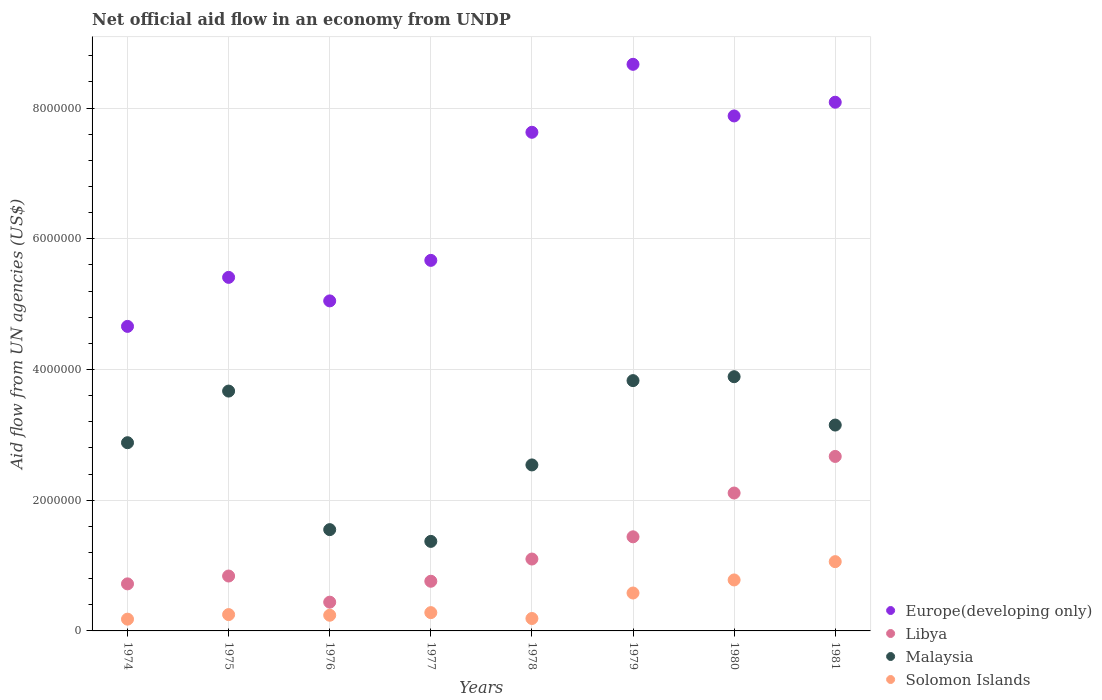How many different coloured dotlines are there?
Your response must be concise. 4. Is the number of dotlines equal to the number of legend labels?
Your answer should be compact. Yes. What is the net official aid flow in Libya in 1981?
Offer a terse response. 2.67e+06. Across all years, what is the maximum net official aid flow in Malaysia?
Offer a terse response. 3.89e+06. Across all years, what is the minimum net official aid flow in Europe(developing only)?
Your answer should be compact. 4.66e+06. In which year was the net official aid flow in Malaysia maximum?
Provide a succinct answer. 1980. In which year was the net official aid flow in Solomon Islands minimum?
Provide a short and direct response. 1974. What is the total net official aid flow in Libya in the graph?
Your response must be concise. 1.01e+07. What is the difference between the net official aid flow in Solomon Islands in 1975 and that in 1977?
Provide a succinct answer. -3.00e+04. What is the difference between the net official aid flow in Solomon Islands in 1981 and the net official aid flow in Libya in 1976?
Your answer should be compact. 6.20e+05. What is the average net official aid flow in Solomon Islands per year?
Your response must be concise. 4.45e+05. In how many years, is the net official aid flow in Europe(developing only) greater than 4000000 US$?
Offer a very short reply. 8. What is the ratio of the net official aid flow in Solomon Islands in 1976 to that in 1979?
Ensure brevity in your answer.  0.41. Is the net official aid flow in Libya in 1979 less than that in 1981?
Make the answer very short. Yes. Is the difference between the net official aid flow in Libya in 1975 and 1979 greater than the difference between the net official aid flow in Solomon Islands in 1975 and 1979?
Offer a terse response. No. What is the difference between the highest and the lowest net official aid flow in Europe(developing only)?
Your answer should be compact. 4.01e+06. In how many years, is the net official aid flow in Malaysia greater than the average net official aid flow in Malaysia taken over all years?
Keep it short and to the point. 5. Is it the case that in every year, the sum of the net official aid flow in Solomon Islands and net official aid flow in Europe(developing only)  is greater than the net official aid flow in Malaysia?
Your answer should be compact. Yes. Is the net official aid flow in Solomon Islands strictly greater than the net official aid flow in Malaysia over the years?
Provide a short and direct response. No. How many dotlines are there?
Your answer should be very brief. 4. What is the difference between two consecutive major ticks on the Y-axis?
Keep it short and to the point. 2.00e+06. Are the values on the major ticks of Y-axis written in scientific E-notation?
Offer a very short reply. No. Does the graph contain any zero values?
Give a very brief answer. No. Does the graph contain grids?
Make the answer very short. Yes. Where does the legend appear in the graph?
Provide a succinct answer. Bottom right. How many legend labels are there?
Make the answer very short. 4. What is the title of the graph?
Your response must be concise. Net official aid flow in an economy from UNDP. Does "Denmark" appear as one of the legend labels in the graph?
Your answer should be very brief. No. What is the label or title of the X-axis?
Offer a very short reply. Years. What is the label or title of the Y-axis?
Provide a short and direct response. Aid flow from UN agencies (US$). What is the Aid flow from UN agencies (US$) in Europe(developing only) in 1974?
Offer a terse response. 4.66e+06. What is the Aid flow from UN agencies (US$) in Libya in 1974?
Keep it short and to the point. 7.20e+05. What is the Aid flow from UN agencies (US$) in Malaysia in 1974?
Offer a very short reply. 2.88e+06. What is the Aid flow from UN agencies (US$) of Solomon Islands in 1974?
Offer a very short reply. 1.80e+05. What is the Aid flow from UN agencies (US$) of Europe(developing only) in 1975?
Offer a terse response. 5.41e+06. What is the Aid flow from UN agencies (US$) in Libya in 1975?
Offer a very short reply. 8.40e+05. What is the Aid flow from UN agencies (US$) in Malaysia in 1975?
Offer a very short reply. 3.67e+06. What is the Aid flow from UN agencies (US$) in Europe(developing only) in 1976?
Your answer should be compact. 5.05e+06. What is the Aid flow from UN agencies (US$) in Malaysia in 1976?
Provide a succinct answer. 1.55e+06. What is the Aid flow from UN agencies (US$) of Europe(developing only) in 1977?
Ensure brevity in your answer.  5.67e+06. What is the Aid flow from UN agencies (US$) in Libya in 1977?
Provide a succinct answer. 7.60e+05. What is the Aid flow from UN agencies (US$) of Malaysia in 1977?
Keep it short and to the point. 1.37e+06. What is the Aid flow from UN agencies (US$) of Europe(developing only) in 1978?
Offer a very short reply. 7.63e+06. What is the Aid flow from UN agencies (US$) of Libya in 1978?
Give a very brief answer. 1.10e+06. What is the Aid flow from UN agencies (US$) in Malaysia in 1978?
Keep it short and to the point. 2.54e+06. What is the Aid flow from UN agencies (US$) of Europe(developing only) in 1979?
Offer a terse response. 8.67e+06. What is the Aid flow from UN agencies (US$) of Libya in 1979?
Offer a terse response. 1.44e+06. What is the Aid flow from UN agencies (US$) in Malaysia in 1979?
Provide a succinct answer. 3.83e+06. What is the Aid flow from UN agencies (US$) of Solomon Islands in 1979?
Provide a short and direct response. 5.80e+05. What is the Aid flow from UN agencies (US$) in Europe(developing only) in 1980?
Your answer should be compact. 7.88e+06. What is the Aid flow from UN agencies (US$) of Libya in 1980?
Your response must be concise. 2.11e+06. What is the Aid flow from UN agencies (US$) in Malaysia in 1980?
Your answer should be compact. 3.89e+06. What is the Aid flow from UN agencies (US$) in Solomon Islands in 1980?
Your response must be concise. 7.80e+05. What is the Aid flow from UN agencies (US$) of Europe(developing only) in 1981?
Give a very brief answer. 8.09e+06. What is the Aid flow from UN agencies (US$) in Libya in 1981?
Your answer should be very brief. 2.67e+06. What is the Aid flow from UN agencies (US$) in Malaysia in 1981?
Offer a very short reply. 3.15e+06. What is the Aid flow from UN agencies (US$) of Solomon Islands in 1981?
Your answer should be very brief. 1.06e+06. Across all years, what is the maximum Aid flow from UN agencies (US$) of Europe(developing only)?
Offer a very short reply. 8.67e+06. Across all years, what is the maximum Aid flow from UN agencies (US$) in Libya?
Ensure brevity in your answer.  2.67e+06. Across all years, what is the maximum Aid flow from UN agencies (US$) of Malaysia?
Your answer should be compact. 3.89e+06. Across all years, what is the maximum Aid flow from UN agencies (US$) in Solomon Islands?
Make the answer very short. 1.06e+06. Across all years, what is the minimum Aid flow from UN agencies (US$) of Europe(developing only)?
Make the answer very short. 4.66e+06. Across all years, what is the minimum Aid flow from UN agencies (US$) of Malaysia?
Your response must be concise. 1.37e+06. What is the total Aid flow from UN agencies (US$) in Europe(developing only) in the graph?
Your response must be concise. 5.31e+07. What is the total Aid flow from UN agencies (US$) in Libya in the graph?
Ensure brevity in your answer.  1.01e+07. What is the total Aid flow from UN agencies (US$) of Malaysia in the graph?
Make the answer very short. 2.29e+07. What is the total Aid flow from UN agencies (US$) of Solomon Islands in the graph?
Provide a short and direct response. 3.56e+06. What is the difference between the Aid flow from UN agencies (US$) in Europe(developing only) in 1974 and that in 1975?
Offer a very short reply. -7.50e+05. What is the difference between the Aid flow from UN agencies (US$) of Libya in 1974 and that in 1975?
Ensure brevity in your answer.  -1.20e+05. What is the difference between the Aid flow from UN agencies (US$) in Malaysia in 1974 and that in 1975?
Offer a terse response. -7.90e+05. What is the difference between the Aid flow from UN agencies (US$) of Europe(developing only) in 1974 and that in 1976?
Your answer should be very brief. -3.90e+05. What is the difference between the Aid flow from UN agencies (US$) of Libya in 1974 and that in 1976?
Make the answer very short. 2.80e+05. What is the difference between the Aid flow from UN agencies (US$) in Malaysia in 1974 and that in 1976?
Your response must be concise. 1.33e+06. What is the difference between the Aid flow from UN agencies (US$) of Solomon Islands in 1974 and that in 1976?
Your response must be concise. -6.00e+04. What is the difference between the Aid flow from UN agencies (US$) in Europe(developing only) in 1974 and that in 1977?
Make the answer very short. -1.01e+06. What is the difference between the Aid flow from UN agencies (US$) of Libya in 1974 and that in 1977?
Offer a very short reply. -4.00e+04. What is the difference between the Aid flow from UN agencies (US$) of Malaysia in 1974 and that in 1977?
Provide a succinct answer. 1.51e+06. What is the difference between the Aid flow from UN agencies (US$) of Europe(developing only) in 1974 and that in 1978?
Offer a terse response. -2.97e+06. What is the difference between the Aid flow from UN agencies (US$) in Libya in 1974 and that in 1978?
Provide a short and direct response. -3.80e+05. What is the difference between the Aid flow from UN agencies (US$) in Europe(developing only) in 1974 and that in 1979?
Your answer should be very brief. -4.01e+06. What is the difference between the Aid flow from UN agencies (US$) in Libya in 1974 and that in 1979?
Give a very brief answer. -7.20e+05. What is the difference between the Aid flow from UN agencies (US$) of Malaysia in 1974 and that in 1979?
Make the answer very short. -9.50e+05. What is the difference between the Aid flow from UN agencies (US$) of Solomon Islands in 1974 and that in 1979?
Keep it short and to the point. -4.00e+05. What is the difference between the Aid flow from UN agencies (US$) of Europe(developing only) in 1974 and that in 1980?
Your response must be concise. -3.22e+06. What is the difference between the Aid flow from UN agencies (US$) in Libya in 1974 and that in 1980?
Ensure brevity in your answer.  -1.39e+06. What is the difference between the Aid flow from UN agencies (US$) of Malaysia in 1974 and that in 1980?
Your answer should be very brief. -1.01e+06. What is the difference between the Aid flow from UN agencies (US$) in Solomon Islands in 1974 and that in 1980?
Your answer should be very brief. -6.00e+05. What is the difference between the Aid flow from UN agencies (US$) in Europe(developing only) in 1974 and that in 1981?
Give a very brief answer. -3.43e+06. What is the difference between the Aid flow from UN agencies (US$) in Libya in 1974 and that in 1981?
Your response must be concise. -1.95e+06. What is the difference between the Aid flow from UN agencies (US$) of Solomon Islands in 1974 and that in 1981?
Provide a short and direct response. -8.80e+05. What is the difference between the Aid flow from UN agencies (US$) in Europe(developing only) in 1975 and that in 1976?
Offer a terse response. 3.60e+05. What is the difference between the Aid flow from UN agencies (US$) in Libya in 1975 and that in 1976?
Provide a short and direct response. 4.00e+05. What is the difference between the Aid flow from UN agencies (US$) of Malaysia in 1975 and that in 1976?
Make the answer very short. 2.12e+06. What is the difference between the Aid flow from UN agencies (US$) in Malaysia in 1975 and that in 1977?
Provide a short and direct response. 2.30e+06. What is the difference between the Aid flow from UN agencies (US$) in Europe(developing only) in 1975 and that in 1978?
Give a very brief answer. -2.22e+06. What is the difference between the Aid flow from UN agencies (US$) of Malaysia in 1975 and that in 1978?
Your answer should be very brief. 1.13e+06. What is the difference between the Aid flow from UN agencies (US$) of Solomon Islands in 1975 and that in 1978?
Offer a very short reply. 6.00e+04. What is the difference between the Aid flow from UN agencies (US$) in Europe(developing only) in 1975 and that in 1979?
Ensure brevity in your answer.  -3.26e+06. What is the difference between the Aid flow from UN agencies (US$) in Libya in 1975 and that in 1979?
Keep it short and to the point. -6.00e+05. What is the difference between the Aid flow from UN agencies (US$) of Solomon Islands in 1975 and that in 1979?
Your answer should be compact. -3.30e+05. What is the difference between the Aid flow from UN agencies (US$) of Europe(developing only) in 1975 and that in 1980?
Your answer should be compact. -2.47e+06. What is the difference between the Aid flow from UN agencies (US$) in Libya in 1975 and that in 1980?
Provide a short and direct response. -1.27e+06. What is the difference between the Aid flow from UN agencies (US$) in Malaysia in 1975 and that in 1980?
Ensure brevity in your answer.  -2.20e+05. What is the difference between the Aid flow from UN agencies (US$) in Solomon Islands in 1975 and that in 1980?
Your answer should be compact. -5.30e+05. What is the difference between the Aid flow from UN agencies (US$) of Europe(developing only) in 1975 and that in 1981?
Provide a succinct answer. -2.68e+06. What is the difference between the Aid flow from UN agencies (US$) in Libya in 1975 and that in 1981?
Provide a succinct answer. -1.83e+06. What is the difference between the Aid flow from UN agencies (US$) of Malaysia in 1975 and that in 1981?
Offer a very short reply. 5.20e+05. What is the difference between the Aid flow from UN agencies (US$) of Solomon Islands in 1975 and that in 1981?
Make the answer very short. -8.10e+05. What is the difference between the Aid flow from UN agencies (US$) of Europe(developing only) in 1976 and that in 1977?
Provide a succinct answer. -6.20e+05. What is the difference between the Aid flow from UN agencies (US$) of Libya in 1976 and that in 1977?
Ensure brevity in your answer.  -3.20e+05. What is the difference between the Aid flow from UN agencies (US$) of Solomon Islands in 1976 and that in 1977?
Make the answer very short. -4.00e+04. What is the difference between the Aid flow from UN agencies (US$) of Europe(developing only) in 1976 and that in 1978?
Offer a terse response. -2.58e+06. What is the difference between the Aid flow from UN agencies (US$) in Libya in 1976 and that in 1978?
Offer a very short reply. -6.60e+05. What is the difference between the Aid flow from UN agencies (US$) in Malaysia in 1976 and that in 1978?
Keep it short and to the point. -9.90e+05. What is the difference between the Aid flow from UN agencies (US$) in Europe(developing only) in 1976 and that in 1979?
Offer a terse response. -3.62e+06. What is the difference between the Aid flow from UN agencies (US$) in Malaysia in 1976 and that in 1979?
Offer a terse response. -2.28e+06. What is the difference between the Aid flow from UN agencies (US$) of Europe(developing only) in 1976 and that in 1980?
Give a very brief answer. -2.83e+06. What is the difference between the Aid flow from UN agencies (US$) in Libya in 1976 and that in 1980?
Offer a terse response. -1.67e+06. What is the difference between the Aid flow from UN agencies (US$) of Malaysia in 1976 and that in 1980?
Your answer should be very brief. -2.34e+06. What is the difference between the Aid flow from UN agencies (US$) of Solomon Islands in 1976 and that in 1980?
Give a very brief answer. -5.40e+05. What is the difference between the Aid flow from UN agencies (US$) of Europe(developing only) in 1976 and that in 1981?
Provide a short and direct response. -3.04e+06. What is the difference between the Aid flow from UN agencies (US$) of Libya in 1976 and that in 1981?
Your response must be concise. -2.23e+06. What is the difference between the Aid flow from UN agencies (US$) of Malaysia in 1976 and that in 1981?
Your answer should be compact. -1.60e+06. What is the difference between the Aid flow from UN agencies (US$) of Solomon Islands in 1976 and that in 1981?
Provide a succinct answer. -8.20e+05. What is the difference between the Aid flow from UN agencies (US$) in Europe(developing only) in 1977 and that in 1978?
Your answer should be very brief. -1.96e+06. What is the difference between the Aid flow from UN agencies (US$) of Libya in 1977 and that in 1978?
Give a very brief answer. -3.40e+05. What is the difference between the Aid flow from UN agencies (US$) in Malaysia in 1977 and that in 1978?
Keep it short and to the point. -1.17e+06. What is the difference between the Aid flow from UN agencies (US$) of Europe(developing only) in 1977 and that in 1979?
Ensure brevity in your answer.  -3.00e+06. What is the difference between the Aid flow from UN agencies (US$) in Libya in 1977 and that in 1979?
Provide a succinct answer. -6.80e+05. What is the difference between the Aid flow from UN agencies (US$) of Malaysia in 1977 and that in 1979?
Make the answer very short. -2.46e+06. What is the difference between the Aid flow from UN agencies (US$) in Europe(developing only) in 1977 and that in 1980?
Provide a short and direct response. -2.21e+06. What is the difference between the Aid flow from UN agencies (US$) in Libya in 1977 and that in 1980?
Keep it short and to the point. -1.35e+06. What is the difference between the Aid flow from UN agencies (US$) in Malaysia in 1977 and that in 1980?
Ensure brevity in your answer.  -2.52e+06. What is the difference between the Aid flow from UN agencies (US$) of Solomon Islands in 1977 and that in 1980?
Provide a succinct answer. -5.00e+05. What is the difference between the Aid flow from UN agencies (US$) in Europe(developing only) in 1977 and that in 1981?
Your answer should be compact. -2.42e+06. What is the difference between the Aid flow from UN agencies (US$) in Libya in 1977 and that in 1981?
Give a very brief answer. -1.91e+06. What is the difference between the Aid flow from UN agencies (US$) of Malaysia in 1977 and that in 1981?
Provide a short and direct response. -1.78e+06. What is the difference between the Aid flow from UN agencies (US$) of Solomon Islands in 1977 and that in 1981?
Give a very brief answer. -7.80e+05. What is the difference between the Aid flow from UN agencies (US$) in Europe(developing only) in 1978 and that in 1979?
Your answer should be very brief. -1.04e+06. What is the difference between the Aid flow from UN agencies (US$) of Libya in 1978 and that in 1979?
Your answer should be very brief. -3.40e+05. What is the difference between the Aid flow from UN agencies (US$) of Malaysia in 1978 and that in 1979?
Your answer should be very brief. -1.29e+06. What is the difference between the Aid flow from UN agencies (US$) in Solomon Islands in 1978 and that in 1979?
Your answer should be very brief. -3.90e+05. What is the difference between the Aid flow from UN agencies (US$) in Libya in 1978 and that in 1980?
Your answer should be compact. -1.01e+06. What is the difference between the Aid flow from UN agencies (US$) of Malaysia in 1978 and that in 1980?
Keep it short and to the point. -1.35e+06. What is the difference between the Aid flow from UN agencies (US$) in Solomon Islands in 1978 and that in 1980?
Your answer should be compact. -5.90e+05. What is the difference between the Aid flow from UN agencies (US$) in Europe(developing only) in 1978 and that in 1981?
Provide a succinct answer. -4.60e+05. What is the difference between the Aid flow from UN agencies (US$) of Libya in 1978 and that in 1981?
Your answer should be compact. -1.57e+06. What is the difference between the Aid flow from UN agencies (US$) of Malaysia in 1978 and that in 1981?
Make the answer very short. -6.10e+05. What is the difference between the Aid flow from UN agencies (US$) in Solomon Islands in 1978 and that in 1981?
Your answer should be compact. -8.70e+05. What is the difference between the Aid flow from UN agencies (US$) in Europe(developing only) in 1979 and that in 1980?
Provide a short and direct response. 7.90e+05. What is the difference between the Aid flow from UN agencies (US$) of Libya in 1979 and that in 1980?
Your answer should be very brief. -6.70e+05. What is the difference between the Aid flow from UN agencies (US$) in Europe(developing only) in 1979 and that in 1981?
Keep it short and to the point. 5.80e+05. What is the difference between the Aid flow from UN agencies (US$) in Libya in 1979 and that in 1981?
Keep it short and to the point. -1.23e+06. What is the difference between the Aid flow from UN agencies (US$) of Malaysia in 1979 and that in 1981?
Provide a succinct answer. 6.80e+05. What is the difference between the Aid flow from UN agencies (US$) in Solomon Islands in 1979 and that in 1981?
Your answer should be compact. -4.80e+05. What is the difference between the Aid flow from UN agencies (US$) of Libya in 1980 and that in 1981?
Provide a short and direct response. -5.60e+05. What is the difference between the Aid flow from UN agencies (US$) of Malaysia in 1980 and that in 1981?
Ensure brevity in your answer.  7.40e+05. What is the difference between the Aid flow from UN agencies (US$) of Solomon Islands in 1980 and that in 1981?
Your answer should be compact. -2.80e+05. What is the difference between the Aid flow from UN agencies (US$) in Europe(developing only) in 1974 and the Aid flow from UN agencies (US$) in Libya in 1975?
Keep it short and to the point. 3.82e+06. What is the difference between the Aid flow from UN agencies (US$) in Europe(developing only) in 1974 and the Aid flow from UN agencies (US$) in Malaysia in 1975?
Give a very brief answer. 9.90e+05. What is the difference between the Aid flow from UN agencies (US$) in Europe(developing only) in 1974 and the Aid flow from UN agencies (US$) in Solomon Islands in 1975?
Provide a succinct answer. 4.41e+06. What is the difference between the Aid flow from UN agencies (US$) in Libya in 1974 and the Aid flow from UN agencies (US$) in Malaysia in 1975?
Provide a short and direct response. -2.95e+06. What is the difference between the Aid flow from UN agencies (US$) of Libya in 1974 and the Aid flow from UN agencies (US$) of Solomon Islands in 1975?
Provide a succinct answer. 4.70e+05. What is the difference between the Aid flow from UN agencies (US$) of Malaysia in 1974 and the Aid flow from UN agencies (US$) of Solomon Islands in 1975?
Ensure brevity in your answer.  2.63e+06. What is the difference between the Aid flow from UN agencies (US$) of Europe(developing only) in 1974 and the Aid flow from UN agencies (US$) of Libya in 1976?
Make the answer very short. 4.22e+06. What is the difference between the Aid flow from UN agencies (US$) of Europe(developing only) in 1974 and the Aid flow from UN agencies (US$) of Malaysia in 1976?
Your response must be concise. 3.11e+06. What is the difference between the Aid flow from UN agencies (US$) of Europe(developing only) in 1974 and the Aid flow from UN agencies (US$) of Solomon Islands in 1976?
Ensure brevity in your answer.  4.42e+06. What is the difference between the Aid flow from UN agencies (US$) in Libya in 1974 and the Aid flow from UN agencies (US$) in Malaysia in 1976?
Your response must be concise. -8.30e+05. What is the difference between the Aid flow from UN agencies (US$) of Malaysia in 1974 and the Aid flow from UN agencies (US$) of Solomon Islands in 1976?
Your response must be concise. 2.64e+06. What is the difference between the Aid flow from UN agencies (US$) of Europe(developing only) in 1974 and the Aid flow from UN agencies (US$) of Libya in 1977?
Provide a succinct answer. 3.90e+06. What is the difference between the Aid flow from UN agencies (US$) of Europe(developing only) in 1974 and the Aid flow from UN agencies (US$) of Malaysia in 1977?
Ensure brevity in your answer.  3.29e+06. What is the difference between the Aid flow from UN agencies (US$) of Europe(developing only) in 1974 and the Aid flow from UN agencies (US$) of Solomon Islands in 1977?
Your response must be concise. 4.38e+06. What is the difference between the Aid flow from UN agencies (US$) in Libya in 1974 and the Aid flow from UN agencies (US$) in Malaysia in 1977?
Offer a very short reply. -6.50e+05. What is the difference between the Aid flow from UN agencies (US$) of Malaysia in 1974 and the Aid flow from UN agencies (US$) of Solomon Islands in 1977?
Provide a succinct answer. 2.60e+06. What is the difference between the Aid flow from UN agencies (US$) of Europe(developing only) in 1974 and the Aid flow from UN agencies (US$) of Libya in 1978?
Offer a very short reply. 3.56e+06. What is the difference between the Aid flow from UN agencies (US$) of Europe(developing only) in 1974 and the Aid flow from UN agencies (US$) of Malaysia in 1978?
Give a very brief answer. 2.12e+06. What is the difference between the Aid flow from UN agencies (US$) of Europe(developing only) in 1974 and the Aid flow from UN agencies (US$) of Solomon Islands in 1978?
Keep it short and to the point. 4.47e+06. What is the difference between the Aid flow from UN agencies (US$) in Libya in 1974 and the Aid flow from UN agencies (US$) in Malaysia in 1978?
Your answer should be compact. -1.82e+06. What is the difference between the Aid flow from UN agencies (US$) of Libya in 1974 and the Aid flow from UN agencies (US$) of Solomon Islands in 1978?
Your answer should be compact. 5.30e+05. What is the difference between the Aid flow from UN agencies (US$) in Malaysia in 1974 and the Aid flow from UN agencies (US$) in Solomon Islands in 1978?
Your answer should be very brief. 2.69e+06. What is the difference between the Aid flow from UN agencies (US$) in Europe(developing only) in 1974 and the Aid flow from UN agencies (US$) in Libya in 1979?
Your answer should be very brief. 3.22e+06. What is the difference between the Aid flow from UN agencies (US$) in Europe(developing only) in 1974 and the Aid flow from UN agencies (US$) in Malaysia in 1979?
Provide a short and direct response. 8.30e+05. What is the difference between the Aid flow from UN agencies (US$) of Europe(developing only) in 1974 and the Aid flow from UN agencies (US$) of Solomon Islands in 1979?
Your answer should be very brief. 4.08e+06. What is the difference between the Aid flow from UN agencies (US$) in Libya in 1974 and the Aid flow from UN agencies (US$) in Malaysia in 1979?
Provide a succinct answer. -3.11e+06. What is the difference between the Aid flow from UN agencies (US$) in Libya in 1974 and the Aid flow from UN agencies (US$) in Solomon Islands in 1979?
Your answer should be very brief. 1.40e+05. What is the difference between the Aid flow from UN agencies (US$) in Malaysia in 1974 and the Aid flow from UN agencies (US$) in Solomon Islands in 1979?
Keep it short and to the point. 2.30e+06. What is the difference between the Aid flow from UN agencies (US$) of Europe(developing only) in 1974 and the Aid flow from UN agencies (US$) of Libya in 1980?
Offer a terse response. 2.55e+06. What is the difference between the Aid flow from UN agencies (US$) of Europe(developing only) in 1974 and the Aid flow from UN agencies (US$) of Malaysia in 1980?
Provide a succinct answer. 7.70e+05. What is the difference between the Aid flow from UN agencies (US$) of Europe(developing only) in 1974 and the Aid flow from UN agencies (US$) of Solomon Islands in 1980?
Your answer should be compact. 3.88e+06. What is the difference between the Aid flow from UN agencies (US$) of Libya in 1974 and the Aid flow from UN agencies (US$) of Malaysia in 1980?
Provide a succinct answer. -3.17e+06. What is the difference between the Aid flow from UN agencies (US$) in Libya in 1974 and the Aid flow from UN agencies (US$) in Solomon Islands in 1980?
Provide a succinct answer. -6.00e+04. What is the difference between the Aid flow from UN agencies (US$) in Malaysia in 1974 and the Aid flow from UN agencies (US$) in Solomon Islands in 1980?
Keep it short and to the point. 2.10e+06. What is the difference between the Aid flow from UN agencies (US$) of Europe(developing only) in 1974 and the Aid flow from UN agencies (US$) of Libya in 1981?
Your answer should be compact. 1.99e+06. What is the difference between the Aid flow from UN agencies (US$) of Europe(developing only) in 1974 and the Aid flow from UN agencies (US$) of Malaysia in 1981?
Give a very brief answer. 1.51e+06. What is the difference between the Aid flow from UN agencies (US$) in Europe(developing only) in 1974 and the Aid flow from UN agencies (US$) in Solomon Islands in 1981?
Offer a very short reply. 3.60e+06. What is the difference between the Aid flow from UN agencies (US$) of Libya in 1974 and the Aid flow from UN agencies (US$) of Malaysia in 1981?
Provide a short and direct response. -2.43e+06. What is the difference between the Aid flow from UN agencies (US$) in Malaysia in 1974 and the Aid flow from UN agencies (US$) in Solomon Islands in 1981?
Provide a succinct answer. 1.82e+06. What is the difference between the Aid flow from UN agencies (US$) of Europe(developing only) in 1975 and the Aid flow from UN agencies (US$) of Libya in 1976?
Keep it short and to the point. 4.97e+06. What is the difference between the Aid flow from UN agencies (US$) of Europe(developing only) in 1975 and the Aid flow from UN agencies (US$) of Malaysia in 1976?
Provide a short and direct response. 3.86e+06. What is the difference between the Aid flow from UN agencies (US$) of Europe(developing only) in 1975 and the Aid flow from UN agencies (US$) of Solomon Islands in 1976?
Keep it short and to the point. 5.17e+06. What is the difference between the Aid flow from UN agencies (US$) of Libya in 1975 and the Aid flow from UN agencies (US$) of Malaysia in 1976?
Give a very brief answer. -7.10e+05. What is the difference between the Aid flow from UN agencies (US$) of Malaysia in 1975 and the Aid flow from UN agencies (US$) of Solomon Islands in 1976?
Give a very brief answer. 3.43e+06. What is the difference between the Aid flow from UN agencies (US$) in Europe(developing only) in 1975 and the Aid flow from UN agencies (US$) in Libya in 1977?
Provide a succinct answer. 4.65e+06. What is the difference between the Aid flow from UN agencies (US$) in Europe(developing only) in 1975 and the Aid flow from UN agencies (US$) in Malaysia in 1977?
Keep it short and to the point. 4.04e+06. What is the difference between the Aid flow from UN agencies (US$) of Europe(developing only) in 1975 and the Aid flow from UN agencies (US$) of Solomon Islands in 1977?
Provide a succinct answer. 5.13e+06. What is the difference between the Aid flow from UN agencies (US$) in Libya in 1975 and the Aid flow from UN agencies (US$) in Malaysia in 1977?
Make the answer very short. -5.30e+05. What is the difference between the Aid flow from UN agencies (US$) in Libya in 1975 and the Aid flow from UN agencies (US$) in Solomon Islands in 1977?
Keep it short and to the point. 5.60e+05. What is the difference between the Aid flow from UN agencies (US$) of Malaysia in 1975 and the Aid flow from UN agencies (US$) of Solomon Islands in 1977?
Offer a terse response. 3.39e+06. What is the difference between the Aid flow from UN agencies (US$) of Europe(developing only) in 1975 and the Aid flow from UN agencies (US$) of Libya in 1978?
Offer a terse response. 4.31e+06. What is the difference between the Aid flow from UN agencies (US$) of Europe(developing only) in 1975 and the Aid flow from UN agencies (US$) of Malaysia in 1978?
Provide a short and direct response. 2.87e+06. What is the difference between the Aid flow from UN agencies (US$) in Europe(developing only) in 1975 and the Aid flow from UN agencies (US$) in Solomon Islands in 1978?
Offer a very short reply. 5.22e+06. What is the difference between the Aid flow from UN agencies (US$) in Libya in 1975 and the Aid flow from UN agencies (US$) in Malaysia in 1978?
Your answer should be compact. -1.70e+06. What is the difference between the Aid flow from UN agencies (US$) in Libya in 1975 and the Aid flow from UN agencies (US$) in Solomon Islands in 1978?
Provide a short and direct response. 6.50e+05. What is the difference between the Aid flow from UN agencies (US$) of Malaysia in 1975 and the Aid flow from UN agencies (US$) of Solomon Islands in 1978?
Ensure brevity in your answer.  3.48e+06. What is the difference between the Aid flow from UN agencies (US$) of Europe(developing only) in 1975 and the Aid flow from UN agencies (US$) of Libya in 1979?
Provide a succinct answer. 3.97e+06. What is the difference between the Aid flow from UN agencies (US$) of Europe(developing only) in 1975 and the Aid flow from UN agencies (US$) of Malaysia in 1979?
Give a very brief answer. 1.58e+06. What is the difference between the Aid flow from UN agencies (US$) in Europe(developing only) in 1975 and the Aid flow from UN agencies (US$) in Solomon Islands in 1979?
Make the answer very short. 4.83e+06. What is the difference between the Aid flow from UN agencies (US$) of Libya in 1975 and the Aid flow from UN agencies (US$) of Malaysia in 1979?
Give a very brief answer. -2.99e+06. What is the difference between the Aid flow from UN agencies (US$) of Libya in 1975 and the Aid flow from UN agencies (US$) of Solomon Islands in 1979?
Offer a terse response. 2.60e+05. What is the difference between the Aid flow from UN agencies (US$) of Malaysia in 1975 and the Aid flow from UN agencies (US$) of Solomon Islands in 1979?
Offer a very short reply. 3.09e+06. What is the difference between the Aid flow from UN agencies (US$) in Europe(developing only) in 1975 and the Aid flow from UN agencies (US$) in Libya in 1980?
Your answer should be compact. 3.30e+06. What is the difference between the Aid flow from UN agencies (US$) in Europe(developing only) in 1975 and the Aid flow from UN agencies (US$) in Malaysia in 1980?
Keep it short and to the point. 1.52e+06. What is the difference between the Aid flow from UN agencies (US$) of Europe(developing only) in 1975 and the Aid flow from UN agencies (US$) of Solomon Islands in 1980?
Offer a terse response. 4.63e+06. What is the difference between the Aid flow from UN agencies (US$) of Libya in 1975 and the Aid flow from UN agencies (US$) of Malaysia in 1980?
Keep it short and to the point. -3.05e+06. What is the difference between the Aid flow from UN agencies (US$) of Malaysia in 1975 and the Aid flow from UN agencies (US$) of Solomon Islands in 1980?
Give a very brief answer. 2.89e+06. What is the difference between the Aid flow from UN agencies (US$) of Europe(developing only) in 1975 and the Aid flow from UN agencies (US$) of Libya in 1981?
Your response must be concise. 2.74e+06. What is the difference between the Aid flow from UN agencies (US$) of Europe(developing only) in 1975 and the Aid flow from UN agencies (US$) of Malaysia in 1981?
Ensure brevity in your answer.  2.26e+06. What is the difference between the Aid flow from UN agencies (US$) in Europe(developing only) in 1975 and the Aid flow from UN agencies (US$) in Solomon Islands in 1981?
Give a very brief answer. 4.35e+06. What is the difference between the Aid flow from UN agencies (US$) of Libya in 1975 and the Aid flow from UN agencies (US$) of Malaysia in 1981?
Offer a very short reply. -2.31e+06. What is the difference between the Aid flow from UN agencies (US$) of Libya in 1975 and the Aid flow from UN agencies (US$) of Solomon Islands in 1981?
Offer a terse response. -2.20e+05. What is the difference between the Aid flow from UN agencies (US$) of Malaysia in 1975 and the Aid flow from UN agencies (US$) of Solomon Islands in 1981?
Provide a succinct answer. 2.61e+06. What is the difference between the Aid flow from UN agencies (US$) of Europe(developing only) in 1976 and the Aid flow from UN agencies (US$) of Libya in 1977?
Keep it short and to the point. 4.29e+06. What is the difference between the Aid flow from UN agencies (US$) in Europe(developing only) in 1976 and the Aid flow from UN agencies (US$) in Malaysia in 1977?
Offer a terse response. 3.68e+06. What is the difference between the Aid flow from UN agencies (US$) in Europe(developing only) in 1976 and the Aid flow from UN agencies (US$) in Solomon Islands in 1977?
Make the answer very short. 4.77e+06. What is the difference between the Aid flow from UN agencies (US$) in Libya in 1976 and the Aid flow from UN agencies (US$) in Malaysia in 1977?
Offer a terse response. -9.30e+05. What is the difference between the Aid flow from UN agencies (US$) in Malaysia in 1976 and the Aid flow from UN agencies (US$) in Solomon Islands in 1977?
Your answer should be compact. 1.27e+06. What is the difference between the Aid flow from UN agencies (US$) of Europe(developing only) in 1976 and the Aid flow from UN agencies (US$) of Libya in 1978?
Ensure brevity in your answer.  3.95e+06. What is the difference between the Aid flow from UN agencies (US$) in Europe(developing only) in 1976 and the Aid flow from UN agencies (US$) in Malaysia in 1978?
Offer a terse response. 2.51e+06. What is the difference between the Aid flow from UN agencies (US$) in Europe(developing only) in 1976 and the Aid flow from UN agencies (US$) in Solomon Islands in 1978?
Provide a short and direct response. 4.86e+06. What is the difference between the Aid flow from UN agencies (US$) in Libya in 1976 and the Aid flow from UN agencies (US$) in Malaysia in 1978?
Offer a very short reply. -2.10e+06. What is the difference between the Aid flow from UN agencies (US$) in Libya in 1976 and the Aid flow from UN agencies (US$) in Solomon Islands in 1978?
Your answer should be compact. 2.50e+05. What is the difference between the Aid flow from UN agencies (US$) of Malaysia in 1976 and the Aid flow from UN agencies (US$) of Solomon Islands in 1978?
Your answer should be compact. 1.36e+06. What is the difference between the Aid flow from UN agencies (US$) of Europe(developing only) in 1976 and the Aid flow from UN agencies (US$) of Libya in 1979?
Give a very brief answer. 3.61e+06. What is the difference between the Aid flow from UN agencies (US$) in Europe(developing only) in 1976 and the Aid flow from UN agencies (US$) in Malaysia in 1979?
Give a very brief answer. 1.22e+06. What is the difference between the Aid flow from UN agencies (US$) in Europe(developing only) in 1976 and the Aid flow from UN agencies (US$) in Solomon Islands in 1979?
Ensure brevity in your answer.  4.47e+06. What is the difference between the Aid flow from UN agencies (US$) of Libya in 1976 and the Aid flow from UN agencies (US$) of Malaysia in 1979?
Keep it short and to the point. -3.39e+06. What is the difference between the Aid flow from UN agencies (US$) in Malaysia in 1976 and the Aid flow from UN agencies (US$) in Solomon Islands in 1979?
Give a very brief answer. 9.70e+05. What is the difference between the Aid flow from UN agencies (US$) in Europe(developing only) in 1976 and the Aid flow from UN agencies (US$) in Libya in 1980?
Your response must be concise. 2.94e+06. What is the difference between the Aid flow from UN agencies (US$) in Europe(developing only) in 1976 and the Aid flow from UN agencies (US$) in Malaysia in 1980?
Offer a terse response. 1.16e+06. What is the difference between the Aid flow from UN agencies (US$) in Europe(developing only) in 1976 and the Aid flow from UN agencies (US$) in Solomon Islands in 1980?
Provide a succinct answer. 4.27e+06. What is the difference between the Aid flow from UN agencies (US$) in Libya in 1976 and the Aid flow from UN agencies (US$) in Malaysia in 1980?
Your answer should be compact. -3.45e+06. What is the difference between the Aid flow from UN agencies (US$) of Malaysia in 1976 and the Aid flow from UN agencies (US$) of Solomon Islands in 1980?
Make the answer very short. 7.70e+05. What is the difference between the Aid flow from UN agencies (US$) in Europe(developing only) in 1976 and the Aid flow from UN agencies (US$) in Libya in 1981?
Offer a very short reply. 2.38e+06. What is the difference between the Aid flow from UN agencies (US$) in Europe(developing only) in 1976 and the Aid flow from UN agencies (US$) in Malaysia in 1981?
Make the answer very short. 1.90e+06. What is the difference between the Aid flow from UN agencies (US$) in Europe(developing only) in 1976 and the Aid flow from UN agencies (US$) in Solomon Islands in 1981?
Your answer should be very brief. 3.99e+06. What is the difference between the Aid flow from UN agencies (US$) in Libya in 1976 and the Aid flow from UN agencies (US$) in Malaysia in 1981?
Your answer should be very brief. -2.71e+06. What is the difference between the Aid flow from UN agencies (US$) of Libya in 1976 and the Aid flow from UN agencies (US$) of Solomon Islands in 1981?
Your response must be concise. -6.20e+05. What is the difference between the Aid flow from UN agencies (US$) of Europe(developing only) in 1977 and the Aid flow from UN agencies (US$) of Libya in 1978?
Ensure brevity in your answer.  4.57e+06. What is the difference between the Aid flow from UN agencies (US$) of Europe(developing only) in 1977 and the Aid flow from UN agencies (US$) of Malaysia in 1978?
Your response must be concise. 3.13e+06. What is the difference between the Aid flow from UN agencies (US$) in Europe(developing only) in 1977 and the Aid flow from UN agencies (US$) in Solomon Islands in 1978?
Provide a short and direct response. 5.48e+06. What is the difference between the Aid flow from UN agencies (US$) in Libya in 1977 and the Aid flow from UN agencies (US$) in Malaysia in 1978?
Your response must be concise. -1.78e+06. What is the difference between the Aid flow from UN agencies (US$) of Libya in 1977 and the Aid flow from UN agencies (US$) of Solomon Islands in 1978?
Keep it short and to the point. 5.70e+05. What is the difference between the Aid flow from UN agencies (US$) in Malaysia in 1977 and the Aid flow from UN agencies (US$) in Solomon Islands in 1978?
Keep it short and to the point. 1.18e+06. What is the difference between the Aid flow from UN agencies (US$) in Europe(developing only) in 1977 and the Aid flow from UN agencies (US$) in Libya in 1979?
Ensure brevity in your answer.  4.23e+06. What is the difference between the Aid flow from UN agencies (US$) in Europe(developing only) in 1977 and the Aid flow from UN agencies (US$) in Malaysia in 1979?
Give a very brief answer. 1.84e+06. What is the difference between the Aid flow from UN agencies (US$) in Europe(developing only) in 1977 and the Aid flow from UN agencies (US$) in Solomon Islands in 1979?
Provide a short and direct response. 5.09e+06. What is the difference between the Aid flow from UN agencies (US$) of Libya in 1977 and the Aid flow from UN agencies (US$) of Malaysia in 1979?
Provide a short and direct response. -3.07e+06. What is the difference between the Aid flow from UN agencies (US$) in Malaysia in 1977 and the Aid flow from UN agencies (US$) in Solomon Islands in 1979?
Your answer should be compact. 7.90e+05. What is the difference between the Aid flow from UN agencies (US$) of Europe(developing only) in 1977 and the Aid flow from UN agencies (US$) of Libya in 1980?
Give a very brief answer. 3.56e+06. What is the difference between the Aid flow from UN agencies (US$) in Europe(developing only) in 1977 and the Aid flow from UN agencies (US$) in Malaysia in 1980?
Give a very brief answer. 1.78e+06. What is the difference between the Aid flow from UN agencies (US$) in Europe(developing only) in 1977 and the Aid flow from UN agencies (US$) in Solomon Islands in 1980?
Provide a short and direct response. 4.89e+06. What is the difference between the Aid flow from UN agencies (US$) of Libya in 1977 and the Aid flow from UN agencies (US$) of Malaysia in 1980?
Offer a very short reply. -3.13e+06. What is the difference between the Aid flow from UN agencies (US$) of Malaysia in 1977 and the Aid flow from UN agencies (US$) of Solomon Islands in 1980?
Ensure brevity in your answer.  5.90e+05. What is the difference between the Aid flow from UN agencies (US$) of Europe(developing only) in 1977 and the Aid flow from UN agencies (US$) of Malaysia in 1981?
Provide a succinct answer. 2.52e+06. What is the difference between the Aid flow from UN agencies (US$) in Europe(developing only) in 1977 and the Aid flow from UN agencies (US$) in Solomon Islands in 1981?
Provide a succinct answer. 4.61e+06. What is the difference between the Aid flow from UN agencies (US$) in Libya in 1977 and the Aid flow from UN agencies (US$) in Malaysia in 1981?
Give a very brief answer. -2.39e+06. What is the difference between the Aid flow from UN agencies (US$) of Libya in 1977 and the Aid flow from UN agencies (US$) of Solomon Islands in 1981?
Ensure brevity in your answer.  -3.00e+05. What is the difference between the Aid flow from UN agencies (US$) in Malaysia in 1977 and the Aid flow from UN agencies (US$) in Solomon Islands in 1981?
Your answer should be compact. 3.10e+05. What is the difference between the Aid flow from UN agencies (US$) in Europe(developing only) in 1978 and the Aid flow from UN agencies (US$) in Libya in 1979?
Offer a very short reply. 6.19e+06. What is the difference between the Aid flow from UN agencies (US$) in Europe(developing only) in 1978 and the Aid flow from UN agencies (US$) in Malaysia in 1979?
Your response must be concise. 3.80e+06. What is the difference between the Aid flow from UN agencies (US$) in Europe(developing only) in 1978 and the Aid flow from UN agencies (US$) in Solomon Islands in 1979?
Offer a very short reply. 7.05e+06. What is the difference between the Aid flow from UN agencies (US$) in Libya in 1978 and the Aid flow from UN agencies (US$) in Malaysia in 1979?
Your answer should be very brief. -2.73e+06. What is the difference between the Aid flow from UN agencies (US$) in Libya in 1978 and the Aid flow from UN agencies (US$) in Solomon Islands in 1979?
Your response must be concise. 5.20e+05. What is the difference between the Aid flow from UN agencies (US$) in Malaysia in 1978 and the Aid flow from UN agencies (US$) in Solomon Islands in 1979?
Provide a succinct answer. 1.96e+06. What is the difference between the Aid flow from UN agencies (US$) in Europe(developing only) in 1978 and the Aid flow from UN agencies (US$) in Libya in 1980?
Offer a terse response. 5.52e+06. What is the difference between the Aid flow from UN agencies (US$) of Europe(developing only) in 1978 and the Aid flow from UN agencies (US$) of Malaysia in 1980?
Offer a very short reply. 3.74e+06. What is the difference between the Aid flow from UN agencies (US$) of Europe(developing only) in 1978 and the Aid flow from UN agencies (US$) of Solomon Islands in 1980?
Your response must be concise. 6.85e+06. What is the difference between the Aid flow from UN agencies (US$) in Libya in 1978 and the Aid flow from UN agencies (US$) in Malaysia in 1980?
Make the answer very short. -2.79e+06. What is the difference between the Aid flow from UN agencies (US$) of Libya in 1978 and the Aid flow from UN agencies (US$) of Solomon Islands in 1980?
Make the answer very short. 3.20e+05. What is the difference between the Aid flow from UN agencies (US$) in Malaysia in 1978 and the Aid flow from UN agencies (US$) in Solomon Islands in 1980?
Keep it short and to the point. 1.76e+06. What is the difference between the Aid flow from UN agencies (US$) of Europe(developing only) in 1978 and the Aid flow from UN agencies (US$) of Libya in 1981?
Make the answer very short. 4.96e+06. What is the difference between the Aid flow from UN agencies (US$) of Europe(developing only) in 1978 and the Aid flow from UN agencies (US$) of Malaysia in 1981?
Your response must be concise. 4.48e+06. What is the difference between the Aid flow from UN agencies (US$) in Europe(developing only) in 1978 and the Aid flow from UN agencies (US$) in Solomon Islands in 1981?
Offer a very short reply. 6.57e+06. What is the difference between the Aid flow from UN agencies (US$) of Libya in 1978 and the Aid flow from UN agencies (US$) of Malaysia in 1981?
Give a very brief answer. -2.05e+06. What is the difference between the Aid flow from UN agencies (US$) of Malaysia in 1978 and the Aid flow from UN agencies (US$) of Solomon Islands in 1981?
Your answer should be compact. 1.48e+06. What is the difference between the Aid flow from UN agencies (US$) of Europe(developing only) in 1979 and the Aid flow from UN agencies (US$) of Libya in 1980?
Ensure brevity in your answer.  6.56e+06. What is the difference between the Aid flow from UN agencies (US$) of Europe(developing only) in 1979 and the Aid flow from UN agencies (US$) of Malaysia in 1980?
Offer a very short reply. 4.78e+06. What is the difference between the Aid flow from UN agencies (US$) in Europe(developing only) in 1979 and the Aid flow from UN agencies (US$) in Solomon Islands in 1980?
Your answer should be very brief. 7.89e+06. What is the difference between the Aid flow from UN agencies (US$) in Libya in 1979 and the Aid flow from UN agencies (US$) in Malaysia in 1980?
Provide a short and direct response. -2.45e+06. What is the difference between the Aid flow from UN agencies (US$) in Libya in 1979 and the Aid flow from UN agencies (US$) in Solomon Islands in 1980?
Ensure brevity in your answer.  6.60e+05. What is the difference between the Aid flow from UN agencies (US$) in Malaysia in 1979 and the Aid flow from UN agencies (US$) in Solomon Islands in 1980?
Keep it short and to the point. 3.05e+06. What is the difference between the Aid flow from UN agencies (US$) in Europe(developing only) in 1979 and the Aid flow from UN agencies (US$) in Libya in 1981?
Offer a very short reply. 6.00e+06. What is the difference between the Aid flow from UN agencies (US$) of Europe(developing only) in 1979 and the Aid flow from UN agencies (US$) of Malaysia in 1981?
Your response must be concise. 5.52e+06. What is the difference between the Aid flow from UN agencies (US$) in Europe(developing only) in 1979 and the Aid flow from UN agencies (US$) in Solomon Islands in 1981?
Give a very brief answer. 7.61e+06. What is the difference between the Aid flow from UN agencies (US$) in Libya in 1979 and the Aid flow from UN agencies (US$) in Malaysia in 1981?
Your answer should be very brief. -1.71e+06. What is the difference between the Aid flow from UN agencies (US$) in Malaysia in 1979 and the Aid flow from UN agencies (US$) in Solomon Islands in 1981?
Your response must be concise. 2.77e+06. What is the difference between the Aid flow from UN agencies (US$) in Europe(developing only) in 1980 and the Aid flow from UN agencies (US$) in Libya in 1981?
Ensure brevity in your answer.  5.21e+06. What is the difference between the Aid flow from UN agencies (US$) in Europe(developing only) in 1980 and the Aid flow from UN agencies (US$) in Malaysia in 1981?
Give a very brief answer. 4.73e+06. What is the difference between the Aid flow from UN agencies (US$) in Europe(developing only) in 1980 and the Aid flow from UN agencies (US$) in Solomon Islands in 1981?
Ensure brevity in your answer.  6.82e+06. What is the difference between the Aid flow from UN agencies (US$) of Libya in 1980 and the Aid flow from UN agencies (US$) of Malaysia in 1981?
Offer a terse response. -1.04e+06. What is the difference between the Aid flow from UN agencies (US$) in Libya in 1980 and the Aid flow from UN agencies (US$) in Solomon Islands in 1981?
Your response must be concise. 1.05e+06. What is the difference between the Aid flow from UN agencies (US$) of Malaysia in 1980 and the Aid flow from UN agencies (US$) of Solomon Islands in 1981?
Give a very brief answer. 2.83e+06. What is the average Aid flow from UN agencies (US$) in Europe(developing only) per year?
Offer a terse response. 6.63e+06. What is the average Aid flow from UN agencies (US$) in Libya per year?
Keep it short and to the point. 1.26e+06. What is the average Aid flow from UN agencies (US$) in Malaysia per year?
Ensure brevity in your answer.  2.86e+06. What is the average Aid flow from UN agencies (US$) in Solomon Islands per year?
Keep it short and to the point. 4.45e+05. In the year 1974, what is the difference between the Aid flow from UN agencies (US$) in Europe(developing only) and Aid flow from UN agencies (US$) in Libya?
Offer a terse response. 3.94e+06. In the year 1974, what is the difference between the Aid flow from UN agencies (US$) of Europe(developing only) and Aid flow from UN agencies (US$) of Malaysia?
Your answer should be compact. 1.78e+06. In the year 1974, what is the difference between the Aid flow from UN agencies (US$) in Europe(developing only) and Aid flow from UN agencies (US$) in Solomon Islands?
Keep it short and to the point. 4.48e+06. In the year 1974, what is the difference between the Aid flow from UN agencies (US$) in Libya and Aid flow from UN agencies (US$) in Malaysia?
Give a very brief answer. -2.16e+06. In the year 1974, what is the difference between the Aid flow from UN agencies (US$) in Libya and Aid flow from UN agencies (US$) in Solomon Islands?
Your response must be concise. 5.40e+05. In the year 1974, what is the difference between the Aid flow from UN agencies (US$) of Malaysia and Aid flow from UN agencies (US$) of Solomon Islands?
Keep it short and to the point. 2.70e+06. In the year 1975, what is the difference between the Aid flow from UN agencies (US$) in Europe(developing only) and Aid flow from UN agencies (US$) in Libya?
Ensure brevity in your answer.  4.57e+06. In the year 1975, what is the difference between the Aid flow from UN agencies (US$) of Europe(developing only) and Aid flow from UN agencies (US$) of Malaysia?
Your response must be concise. 1.74e+06. In the year 1975, what is the difference between the Aid flow from UN agencies (US$) in Europe(developing only) and Aid flow from UN agencies (US$) in Solomon Islands?
Keep it short and to the point. 5.16e+06. In the year 1975, what is the difference between the Aid flow from UN agencies (US$) in Libya and Aid flow from UN agencies (US$) in Malaysia?
Ensure brevity in your answer.  -2.83e+06. In the year 1975, what is the difference between the Aid flow from UN agencies (US$) of Libya and Aid flow from UN agencies (US$) of Solomon Islands?
Keep it short and to the point. 5.90e+05. In the year 1975, what is the difference between the Aid flow from UN agencies (US$) in Malaysia and Aid flow from UN agencies (US$) in Solomon Islands?
Ensure brevity in your answer.  3.42e+06. In the year 1976, what is the difference between the Aid flow from UN agencies (US$) of Europe(developing only) and Aid flow from UN agencies (US$) of Libya?
Keep it short and to the point. 4.61e+06. In the year 1976, what is the difference between the Aid flow from UN agencies (US$) in Europe(developing only) and Aid flow from UN agencies (US$) in Malaysia?
Provide a short and direct response. 3.50e+06. In the year 1976, what is the difference between the Aid flow from UN agencies (US$) in Europe(developing only) and Aid flow from UN agencies (US$) in Solomon Islands?
Make the answer very short. 4.81e+06. In the year 1976, what is the difference between the Aid flow from UN agencies (US$) in Libya and Aid flow from UN agencies (US$) in Malaysia?
Keep it short and to the point. -1.11e+06. In the year 1976, what is the difference between the Aid flow from UN agencies (US$) in Libya and Aid flow from UN agencies (US$) in Solomon Islands?
Your response must be concise. 2.00e+05. In the year 1976, what is the difference between the Aid flow from UN agencies (US$) in Malaysia and Aid flow from UN agencies (US$) in Solomon Islands?
Offer a terse response. 1.31e+06. In the year 1977, what is the difference between the Aid flow from UN agencies (US$) of Europe(developing only) and Aid flow from UN agencies (US$) of Libya?
Keep it short and to the point. 4.91e+06. In the year 1977, what is the difference between the Aid flow from UN agencies (US$) of Europe(developing only) and Aid flow from UN agencies (US$) of Malaysia?
Your answer should be compact. 4.30e+06. In the year 1977, what is the difference between the Aid flow from UN agencies (US$) of Europe(developing only) and Aid flow from UN agencies (US$) of Solomon Islands?
Provide a short and direct response. 5.39e+06. In the year 1977, what is the difference between the Aid flow from UN agencies (US$) in Libya and Aid flow from UN agencies (US$) in Malaysia?
Provide a short and direct response. -6.10e+05. In the year 1977, what is the difference between the Aid flow from UN agencies (US$) of Malaysia and Aid flow from UN agencies (US$) of Solomon Islands?
Offer a terse response. 1.09e+06. In the year 1978, what is the difference between the Aid flow from UN agencies (US$) of Europe(developing only) and Aid flow from UN agencies (US$) of Libya?
Offer a very short reply. 6.53e+06. In the year 1978, what is the difference between the Aid flow from UN agencies (US$) in Europe(developing only) and Aid flow from UN agencies (US$) in Malaysia?
Keep it short and to the point. 5.09e+06. In the year 1978, what is the difference between the Aid flow from UN agencies (US$) in Europe(developing only) and Aid flow from UN agencies (US$) in Solomon Islands?
Offer a terse response. 7.44e+06. In the year 1978, what is the difference between the Aid flow from UN agencies (US$) in Libya and Aid flow from UN agencies (US$) in Malaysia?
Keep it short and to the point. -1.44e+06. In the year 1978, what is the difference between the Aid flow from UN agencies (US$) of Libya and Aid flow from UN agencies (US$) of Solomon Islands?
Your answer should be compact. 9.10e+05. In the year 1978, what is the difference between the Aid flow from UN agencies (US$) in Malaysia and Aid flow from UN agencies (US$) in Solomon Islands?
Ensure brevity in your answer.  2.35e+06. In the year 1979, what is the difference between the Aid flow from UN agencies (US$) of Europe(developing only) and Aid flow from UN agencies (US$) of Libya?
Keep it short and to the point. 7.23e+06. In the year 1979, what is the difference between the Aid flow from UN agencies (US$) of Europe(developing only) and Aid flow from UN agencies (US$) of Malaysia?
Ensure brevity in your answer.  4.84e+06. In the year 1979, what is the difference between the Aid flow from UN agencies (US$) of Europe(developing only) and Aid flow from UN agencies (US$) of Solomon Islands?
Your answer should be very brief. 8.09e+06. In the year 1979, what is the difference between the Aid flow from UN agencies (US$) of Libya and Aid flow from UN agencies (US$) of Malaysia?
Keep it short and to the point. -2.39e+06. In the year 1979, what is the difference between the Aid flow from UN agencies (US$) of Libya and Aid flow from UN agencies (US$) of Solomon Islands?
Provide a succinct answer. 8.60e+05. In the year 1979, what is the difference between the Aid flow from UN agencies (US$) in Malaysia and Aid flow from UN agencies (US$) in Solomon Islands?
Make the answer very short. 3.25e+06. In the year 1980, what is the difference between the Aid flow from UN agencies (US$) of Europe(developing only) and Aid flow from UN agencies (US$) of Libya?
Make the answer very short. 5.77e+06. In the year 1980, what is the difference between the Aid flow from UN agencies (US$) in Europe(developing only) and Aid flow from UN agencies (US$) in Malaysia?
Provide a short and direct response. 3.99e+06. In the year 1980, what is the difference between the Aid flow from UN agencies (US$) of Europe(developing only) and Aid flow from UN agencies (US$) of Solomon Islands?
Your answer should be very brief. 7.10e+06. In the year 1980, what is the difference between the Aid flow from UN agencies (US$) in Libya and Aid flow from UN agencies (US$) in Malaysia?
Your answer should be compact. -1.78e+06. In the year 1980, what is the difference between the Aid flow from UN agencies (US$) in Libya and Aid flow from UN agencies (US$) in Solomon Islands?
Offer a very short reply. 1.33e+06. In the year 1980, what is the difference between the Aid flow from UN agencies (US$) of Malaysia and Aid flow from UN agencies (US$) of Solomon Islands?
Offer a terse response. 3.11e+06. In the year 1981, what is the difference between the Aid flow from UN agencies (US$) in Europe(developing only) and Aid flow from UN agencies (US$) in Libya?
Give a very brief answer. 5.42e+06. In the year 1981, what is the difference between the Aid flow from UN agencies (US$) in Europe(developing only) and Aid flow from UN agencies (US$) in Malaysia?
Your response must be concise. 4.94e+06. In the year 1981, what is the difference between the Aid flow from UN agencies (US$) in Europe(developing only) and Aid flow from UN agencies (US$) in Solomon Islands?
Keep it short and to the point. 7.03e+06. In the year 1981, what is the difference between the Aid flow from UN agencies (US$) in Libya and Aid flow from UN agencies (US$) in Malaysia?
Your response must be concise. -4.80e+05. In the year 1981, what is the difference between the Aid flow from UN agencies (US$) of Libya and Aid flow from UN agencies (US$) of Solomon Islands?
Your answer should be compact. 1.61e+06. In the year 1981, what is the difference between the Aid flow from UN agencies (US$) in Malaysia and Aid flow from UN agencies (US$) in Solomon Islands?
Your answer should be very brief. 2.09e+06. What is the ratio of the Aid flow from UN agencies (US$) in Europe(developing only) in 1974 to that in 1975?
Give a very brief answer. 0.86. What is the ratio of the Aid flow from UN agencies (US$) in Libya in 1974 to that in 1975?
Give a very brief answer. 0.86. What is the ratio of the Aid flow from UN agencies (US$) of Malaysia in 1974 to that in 1975?
Offer a terse response. 0.78. What is the ratio of the Aid flow from UN agencies (US$) in Solomon Islands in 1974 to that in 1975?
Your answer should be very brief. 0.72. What is the ratio of the Aid flow from UN agencies (US$) of Europe(developing only) in 1974 to that in 1976?
Provide a succinct answer. 0.92. What is the ratio of the Aid flow from UN agencies (US$) in Libya in 1974 to that in 1976?
Your response must be concise. 1.64. What is the ratio of the Aid flow from UN agencies (US$) in Malaysia in 1974 to that in 1976?
Your response must be concise. 1.86. What is the ratio of the Aid flow from UN agencies (US$) of Solomon Islands in 1974 to that in 1976?
Give a very brief answer. 0.75. What is the ratio of the Aid flow from UN agencies (US$) of Europe(developing only) in 1974 to that in 1977?
Offer a terse response. 0.82. What is the ratio of the Aid flow from UN agencies (US$) of Libya in 1974 to that in 1977?
Your answer should be compact. 0.95. What is the ratio of the Aid flow from UN agencies (US$) in Malaysia in 1974 to that in 1977?
Ensure brevity in your answer.  2.1. What is the ratio of the Aid flow from UN agencies (US$) in Solomon Islands in 1974 to that in 1977?
Offer a very short reply. 0.64. What is the ratio of the Aid flow from UN agencies (US$) of Europe(developing only) in 1974 to that in 1978?
Ensure brevity in your answer.  0.61. What is the ratio of the Aid flow from UN agencies (US$) of Libya in 1974 to that in 1978?
Your response must be concise. 0.65. What is the ratio of the Aid flow from UN agencies (US$) of Malaysia in 1974 to that in 1978?
Your answer should be compact. 1.13. What is the ratio of the Aid flow from UN agencies (US$) in Europe(developing only) in 1974 to that in 1979?
Your response must be concise. 0.54. What is the ratio of the Aid flow from UN agencies (US$) in Libya in 1974 to that in 1979?
Keep it short and to the point. 0.5. What is the ratio of the Aid flow from UN agencies (US$) in Malaysia in 1974 to that in 1979?
Provide a short and direct response. 0.75. What is the ratio of the Aid flow from UN agencies (US$) in Solomon Islands in 1974 to that in 1979?
Offer a terse response. 0.31. What is the ratio of the Aid flow from UN agencies (US$) in Europe(developing only) in 1974 to that in 1980?
Keep it short and to the point. 0.59. What is the ratio of the Aid flow from UN agencies (US$) in Libya in 1974 to that in 1980?
Provide a succinct answer. 0.34. What is the ratio of the Aid flow from UN agencies (US$) of Malaysia in 1974 to that in 1980?
Ensure brevity in your answer.  0.74. What is the ratio of the Aid flow from UN agencies (US$) in Solomon Islands in 1974 to that in 1980?
Make the answer very short. 0.23. What is the ratio of the Aid flow from UN agencies (US$) in Europe(developing only) in 1974 to that in 1981?
Offer a terse response. 0.58. What is the ratio of the Aid flow from UN agencies (US$) of Libya in 1974 to that in 1981?
Make the answer very short. 0.27. What is the ratio of the Aid flow from UN agencies (US$) in Malaysia in 1974 to that in 1981?
Ensure brevity in your answer.  0.91. What is the ratio of the Aid flow from UN agencies (US$) of Solomon Islands in 1974 to that in 1981?
Offer a terse response. 0.17. What is the ratio of the Aid flow from UN agencies (US$) in Europe(developing only) in 1975 to that in 1976?
Your answer should be very brief. 1.07. What is the ratio of the Aid flow from UN agencies (US$) of Libya in 1975 to that in 1976?
Your answer should be very brief. 1.91. What is the ratio of the Aid flow from UN agencies (US$) of Malaysia in 1975 to that in 1976?
Provide a short and direct response. 2.37. What is the ratio of the Aid flow from UN agencies (US$) in Solomon Islands in 1975 to that in 1976?
Keep it short and to the point. 1.04. What is the ratio of the Aid flow from UN agencies (US$) of Europe(developing only) in 1975 to that in 1977?
Your response must be concise. 0.95. What is the ratio of the Aid flow from UN agencies (US$) in Libya in 1975 to that in 1977?
Your answer should be very brief. 1.11. What is the ratio of the Aid flow from UN agencies (US$) of Malaysia in 1975 to that in 1977?
Your response must be concise. 2.68. What is the ratio of the Aid flow from UN agencies (US$) in Solomon Islands in 1975 to that in 1977?
Offer a very short reply. 0.89. What is the ratio of the Aid flow from UN agencies (US$) of Europe(developing only) in 1975 to that in 1978?
Your answer should be compact. 0.71. What is the ratio of the Aid flow from UN agencies (US$) in Libya in 1975 to that in 1978?
Your response must be concise. 0.76. What is the ratio of the Aid flow from UN agencies (US$) of Malaysia in 1975 to that in 1978?
Your response must be concise. 1.44. What is the ratio of the Aid flow from UN agencies (US$) of Solomon Islands in 1975 to that in 1978?
Make the answer very short. 1.32. What is the ratio of the Aid flow from UN agencies (US$) in Europe(developing only) in 1975 to that in 1979?
Your answer should be compact. 0.62. What is the ratio of the Aid flow from UN agencies (US$) of Libya in 1975 to that in 1979?
Ensure brevity in your answer.  0.58. What is the ratio of the Aid flow from UN agencies (US$) of Malaysia in 1975 to that in 1979?
Your answer should be very brief. 0.96. What is the ratio of the Aid flow from UN agencies (US$) of Solomon Islands in 1975 to that in 1979?
Offer a terse response. 0.43. What is the ratio of the Aid flow from UN agencies (US$) of Europe(developing only) in 1975 to that in 1980?
Your answer should be compact. 0.69. What is the ratio of the Aid flow from UN agencies (US$) in Libya in 1975 to that in 1980?
Give a very brief answer. 0.4. What is the ratio of the Aid flow from UN agencies (US$) of Malaysia in 1975 to that in 1980?
Give a very brief answer. 0.94. What is the ratio of the Aid flow from UN agencies (US$) in Solomon Islands in 1975 to that in 1980?
Offer a very short reply. 0.32. What is the ratio of the Aid flow from UN agencies (US$) of Europe(developing only) in 1975 to that in 1981?
Provide a short and direct response. 0.67. What is the ratio of the Aid flow from UN agencies (US$) in Libya in 1975 to that in 1981?
Your response must be concise. 0.31. What is the ratio of the Aid flow from UN agencies (US$) of Malaysia in 1975 to that in 1981?
Your answer should be compact. 1.17. What is the ratio of the Aid flow from UN agencies (US$) of Solomon Islands in 1975 to that in 1981?
Keep it short and to the point. 0.24. What is the ratio of the Aid flow from UN agencies (US$) in Europe(developing only) in 1976 to that in 1977?
Make the answer very short. 0.89. What is the ratio of the Aid flow from UN agencies (US$) of Libya in 1976 to that in 1977?
Make the answer very short. 0.58. What is the ratio of the Aid flow from UN agencies (US$) of Malaysia in 1976 to that in 1977?
Give a very brief answer. 1.13. What is the ratio of the Aid flow from UN agencies (US$) in Europe(developing only) in 1976 to that in 1978?
Give a very brief answer. 0.66. What is the ratio of the Aid flow from UN agencies (US$) in Libya in 1976 to that in 1978?
Offer a terse response. 0.4. What is the ratio of the Aid flow from UN agencies (US$) in Malaysia in 1976 to that in 1978?
Keep it short and to the point. 0.61. What is the ratio of the Aid flow from UN agencies (US$) of Solomon Islands in 1976 to that in 1978?
Keep it short and to the point. 1.26. What is the ratio of the Aid flow from UN agencies (US$) of Europe(developing only) in 1976 to that in 1979?
Your response must be concise. 0.58. What is the ratio of the Aid flow from UN agencies (US$) in Libya in 1976 to that in 1979?
Provide a short and direct response. 0.31. What is the ratio of the Aid flow from UN agencies (US$) of Malaysia in 1976 to that in 1979?
Your response must be concise. 0.4. What is the ratio of the Aid flow from UN agencies (US$) in Solomon Islands in 1976 to that in 1979?
Your response must be concise. 0.41. What is the ratio of the Aid flow from UN agencies (US$) of Europe(developing only) in 1976 to that in 1980?
Give a very brief answer. 0.64. What is the ratio of the Aid flow from UN agencies (US$) of Libya in 1976 to that in 1980?
Provide a short and direct response. 0.21. What is the ratio of the Aid flow from UN agencies (US$) of Malaysia in 1976 to that in 1980?
Your answer should be compact. 0.4. What is the ratio of the Aid flow from UN agencies (US$) of Solomon Islands in 1976 to that in 1980?
Your answer should be compact. 0.31. What is the ratio of the Aid flow from UN agencies (US$) of Europe(developing only) in 1976 to that in 1981?
Give a very brief answer. 0.62. What is the ratio of the Aid flow from UN agencies (US$) of Libya in 1976 to that in 1981?
Your answer should be very brief. 0.16. What is the ratio of the Aid flow from UN agencies (US$) of Malaysia in 1976 to that in 1981?
Offer a very short reply. 0.49. What is the ratio of the Aid flow from UN agencies (US$) of Solomon Islands in 1976 to that in 1981?
Give a very brief answer. 0.23. What is the ratio of the Aid flow from UN agencies (US$) of Europe(developing only) in 1977 to that in 1978?
Provide a short and direct response. 0.74. What is the ratio of the Aid flow from UN agencies (US$) of Libya in 1977 to that in 1978?
Provide a succinct answer. 0.69. What is the ratio of the Aid flow from UN agencies (US$) in Malaysia in 1977 to that in 1978?
Offer a terse response. 0.54. What is the ratio of the Aid flow from UN agencies (US$) of Solomon Islands in 1977 to that in 1978?
Your response must be concise. 1.47. What is the ratio of the Aid flow from UN agencies (US$) of Europe(developing only) in 1977 to that in 1979?
Make the answer very short. 0.65. What is the ratio of the Aid flow from UN agencies (US$) of Libya in 1977 to that in 1979?
Provide a succinct answer. 0.53. What is the ratio of the Aid flow from UN agencies (US$) of Malaysia in 1977 to that in 1979?
Offer a very short reply. 0.36. What is the ratio of the Aid flow from UN agencies (US$) in Solomon Islands in 1977 to that in 1979?
Make the answer very short. 0.48. What is the ratio of the Aid flow from UN agencies (US$) of Europe(developing only) in 1977 to that in 1980?
Ensure brevity in your answer.  0.72. What is the ratio of the Aid flow from UN agencies (US$) in Libya in 1977 to that in 1980?
Ensure brevity in your answer.  0.36. What is the ratio of the Aid flow from UN agencies (US$) of Malaysia in 1977 to that in 1980?
Offer a terse response. 0.35. What is the ratio of the Aid flow from UN agencies (US$) of Solomon Islands in 1977 to that in 1980?
Keep it short and to the point. 0.36. What is the ratio of the Aid flow from UN agencies (US$) of Europe(developing only) in 1977 to that in 1981?
Give a very brief answer. 0.7. What is the ratio of the Aid flow from UN agencies (US$) of Libya in 1977 to that in 1981?
Your response must be concise. 0.28. What is the ratio of the Aid flow from UN agencies (US$) in Malaysia in 1977 to that in 1981?
Ensure brevity in your answer.  0.43. What is the ratio of the Aid flow from UN agencies (US$) in Solomon Islands in 1977 to that in 1981?
Your response must be concise. 0.26. What is the ratio of the Aid flow from UN agencies (US$) in Libya in 1978 to that in 1979?
Provide a short and direct response. 0.76. What is the ratio of the Aid flow from UN agencies (US$) in Malaysia in 1978 to that in 1979?
Keep it short and to the point. 0.66. What is the ratio of the Aid flow from UN agencies (US$) in Solomon Islands in 1978 to that in 1979?
Offer a terse response. 0.33. What is the ratio of the Aid flow from UN agencies (US$) in Europe(developing only) in 1978 to that in 1980?
Your answer should be very brief. 0.97. What is the ratio of the Aid flow from UN agencies (US$) in Libya in 1978 to that in 1980?
Offer a very short reply. 0.52. What is the ratio of the Aid flow from UN agencies (US$) of Malaysia in 1978 to that in 1980?
Your response must be concise. 0.65. What is the ratio of the Aid flow from UN agencies (US$) of Solomon Islands in 1978 to that in 1980?
Your answer should be very brief. 0.24. What is the ratio of the Aid flow from UN agencies (US$) in Europe(developing only) in 1978 to that in 1981?
Offer a very short reply. 0.94. What is the ratio of the Aid flow from UN agencies (US$) of Libya in 1978 to that in 1981?
Provide a short and direct response. 0.41. What is the ratio of the Aid flow from UN agencies (US$) in Malaysia in 1978 to that in 1981?
Give a very brief answer. 0.81. What is the ratio of the Aid flow from UN agencies (US$) of Solomon Islands in 1978 to that in 1981?
Give a very brief answer. 0.18. What is the ratio of the Aid flow from UN agencies (US$) in Europe(developing only) in 1979 to that in 1980?
Keep it short and to the point. 1.1. What is the ratio of the Aid flow from UN agencies (US$) of Libya in 1979 to that in 1980?
Give a very brief answer. 0.68. What is the ratio of the Aid flow from UN agencies (US$) in Malaysia in 1979 to that in 1980?
Give a very brief answer. 0.98. What is the ratio of the Aid flow from UN agencies (US$) in Solomon Islands in 1979 to that in 1980?
Your answer should be very brief. 0.74. What is the ratio of the Aid flow from UN agencies (US$) in Europe(developing only) in 1979 to that in 1981?
Offer a very short reply. 1.07. What is the ratio of the Aid flow from UN agencies (US$) of Libya in 1979 to that in 1981?
Keep it short and to the point. 0.54. What is the ratio of the Aid flow from UN agencies (US$) in Malaysia in 1979 to that in 1981?
Your answer should be very brief. 1.22. What is the ratio of the Aid flow from UN agencies (US$) in Solomon Islands in 1979 to that in 1981?
Give a very brief answer. 0.55. What is the ratio of the Aid flow from UN agencies (US$) of Europe(developing only) in 1980 to that in 1981?
Offer a very short reply. 0.97. What is the ratio of the Aid flow from UN agencies (US$) in Libya in 1980 to that in 1981?
Give a very brief answer. 0.79. What is the ratio of the Aid flow from UN agencies (US$) of Malaysia in 1980 to that in 1981?
Your response must be concise. 1.23. What is the ratio of the Aid flow from UN agencies (US$) of Solomon Islands in 1980 to that in 1981?
Your answer should be very brief. 0.74. What is the difference between the highest and the second highest Aid flow from UN agencies (US$) in Europe(developing only)?
Provide a succinct answer. 5.80e+05. What is the difference between the highest and the second highest Aid flow from UN agencies (US$) of Libya?
Offer a very short reply. 5.60e+05. What is the difference between the highest and the second highest Aid flow from UN agencies (US$) of Malaysia?
Offer a terse response. 6.00e+04. What is the difference between the highest and the lowest Aid flow from UN agencies (US$) of Europe(developing only)?
Your response must be concise. 4.01e+06. What is the difference between the highest and the lowest Aid flow from UN agencies (US$) of Libya?
Your answer should be compact. 2.23e+06. What is the difference between the highest and the lowest Aid flow from UN agencies (US$) in Malaysia?
Your answer should be compact. 2.52e+06. What is the difference between the highest and the lowest Aid flow from UN agencies (US$) of Solomon Islands?
Provide a short and direct response. 8.80e+05. 